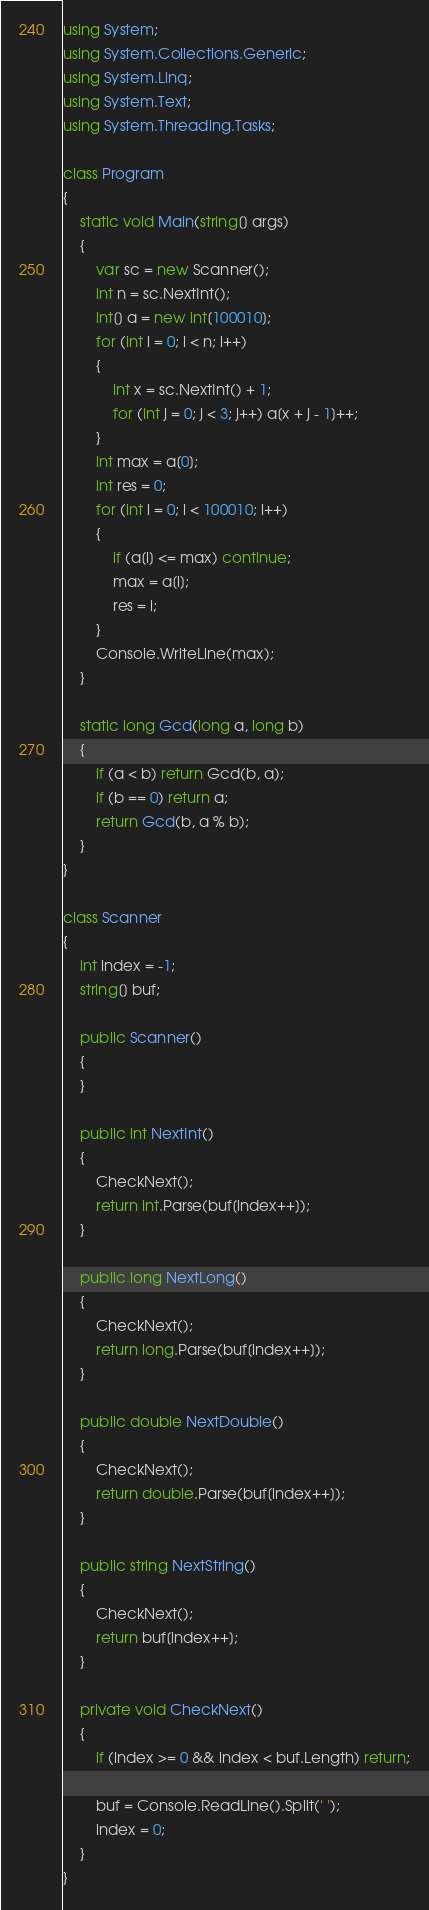<code> <loc_0><loc_0><loc_500><loc_500><_C#_>using System;
using System.Collections.Generic;
using System.Linq;
using System.Text;
using System.Threading.Tasks;

class Program
{
    static void Main(string[] args)
    {
    	var sc = new Scanner();
    	int n = sc.NextInt();
    	int[] a = new int[100010];
    	for (int i = 0; i < n; i++)
    	{
    		int x = sc.NextInt() + 1;
    		for (int j = 0; j < 3; j++) a[x + j - 1]++;
    	}
    	int max = a[0];
    	int res = 0;
    	for (int i = 0; i < 100010; i++)
    	{
    		if (a[i] <= max) continue;
    		max = a[i];
    		res = i;
    	}
    	Console.WriteLine(max);
    }
    
    static long Gcd(long a, long b)
    {
        if (a < b) return Gcd(b, a);
        if (b == 0) return a;
        return Gcd(b, a % b);
    }
}

class Scanner
{
    int index = -1;
    string[] buf;

    public Scanner()
    {
    }

    public int NextInt()
    {
        CheckNext();
        return int.Parse(buf[index++]);
    }
        
    public long NextLong()
    {
    	CheckNext();
    	return long.Parse(buf[index++]);
    }
    
    public double NextDouble()
    {
    	CheckNext();
    	return double.Parse(buf[index++]);
    }

    public string NextString()
    {
        CheckNext();
        return buf[index++];
    }

    private void CheckNext()
    {
        if (index >= 0 && index < buf.Length) return;

        buf = Console.ReadLine().Split(' ');
        index = 0;
    }
}</code> 